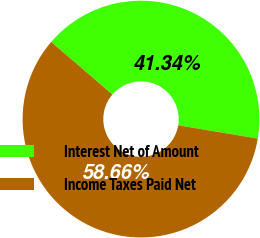<chart> <loc_0><loc_0><loc_500><loc_500><pie_chart><fcel>Interest Net of Amount<fcel>Income Taxes Paid Net<nl><fcel>41.34%<fcel>58.66%<nl></chart> 